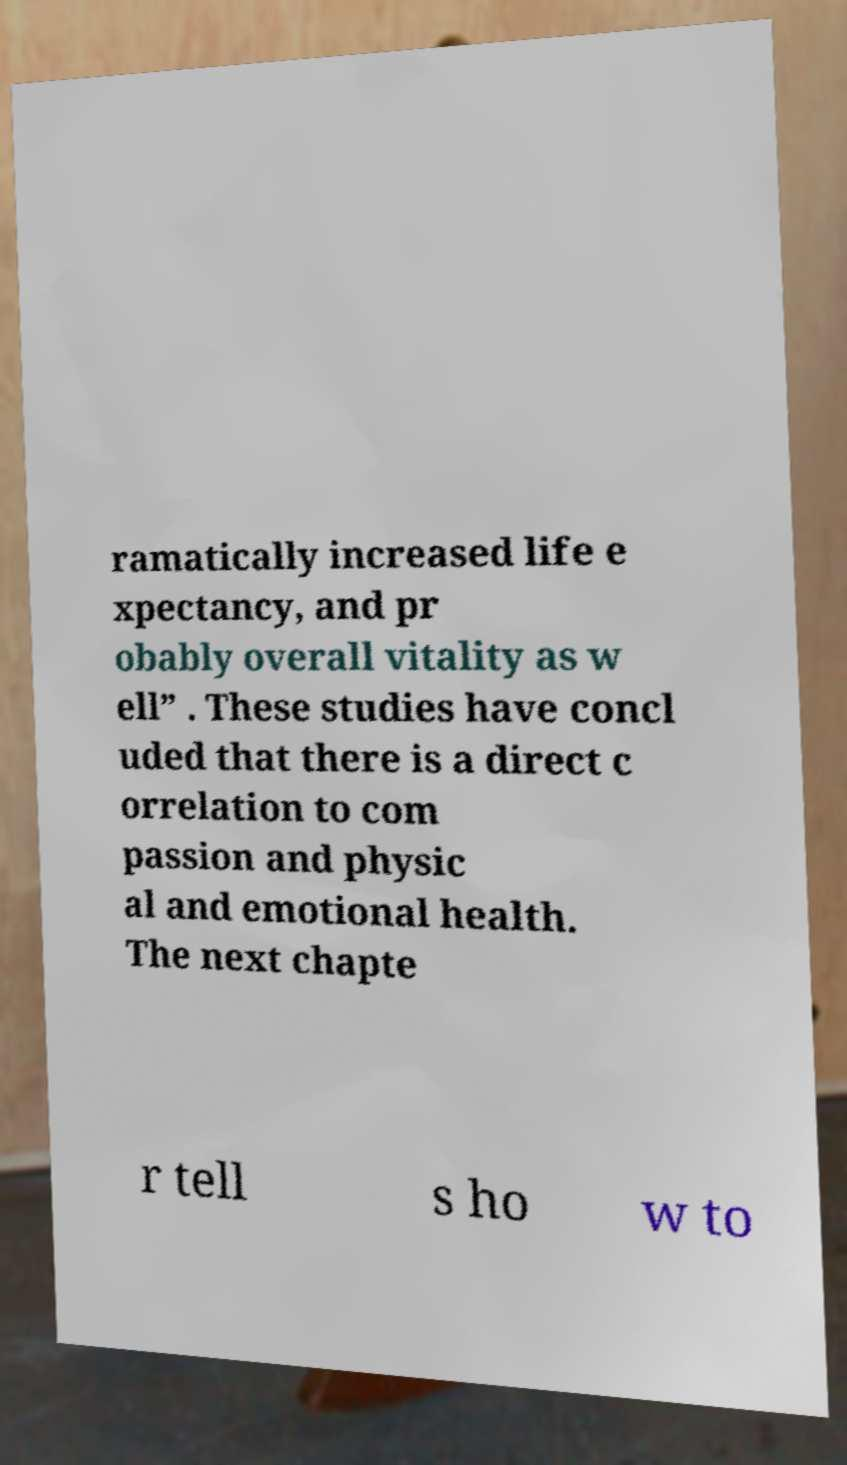There's text embedded in this image that I need extracted. Can you transcribe it verbatim? ramatically increased life e xpectancy, and pr obably overall vitality as w ell” . These studies have concl uded that there is a direct c orrelation to com passion and physic al and emotional health. The next chapte r tell s ho w to 